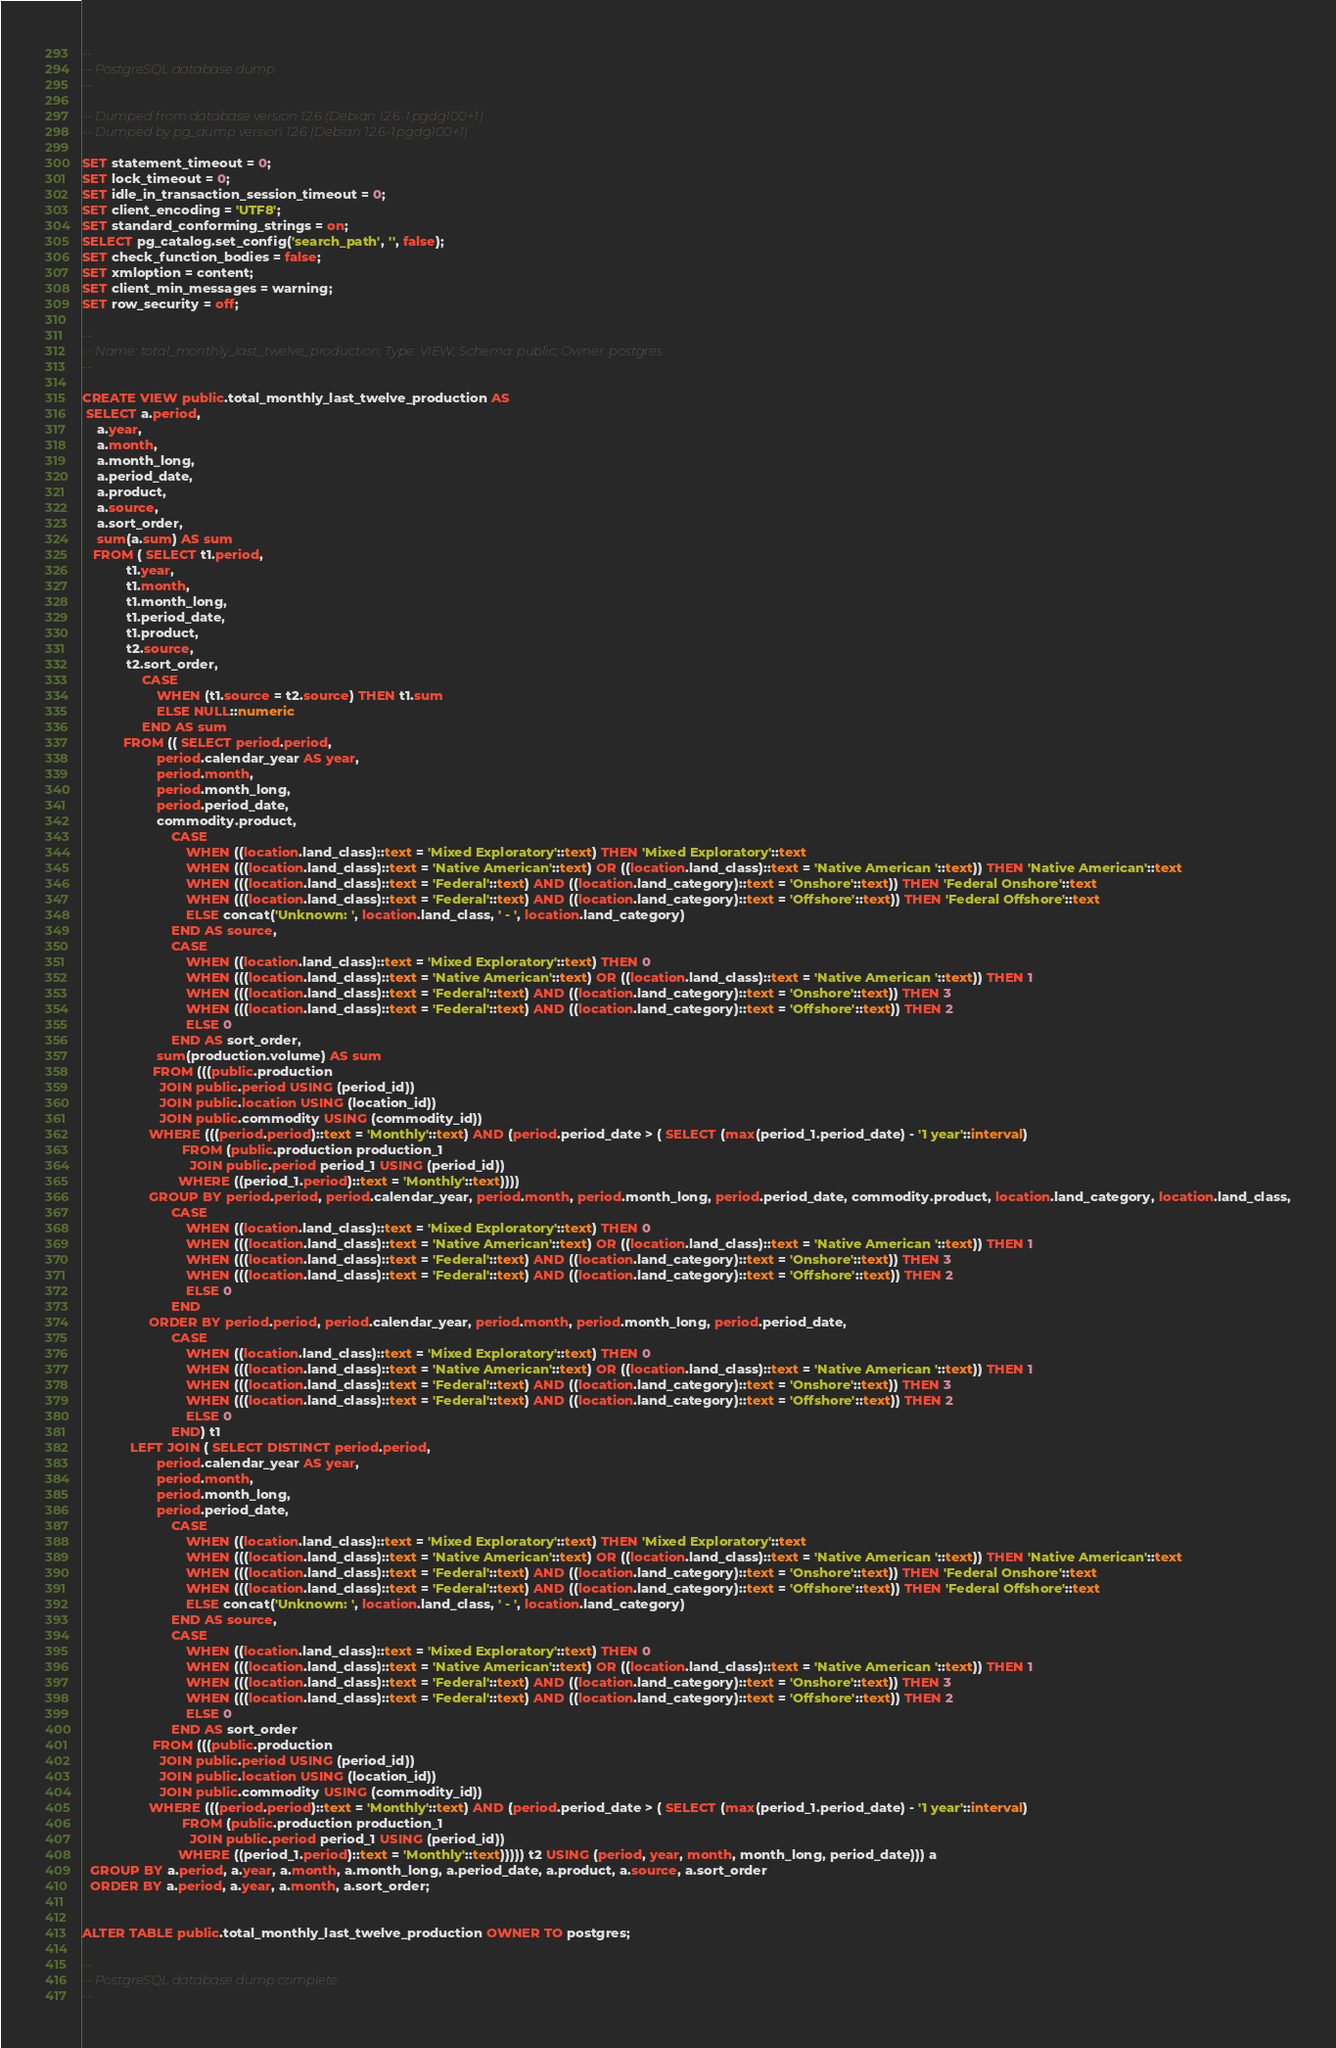<code> <loc_0><loc_0><loc_500><loc_500><_SQL_>--
-- PostgreSQL database dump
--

-- Dumped from database version 12.6 (Debian 12.6-1.pgdg100+1)
-- Dumped by pg_dump version 12.6 (Debian 12.6-1.pgdg100+1)

SET statement_timeout = 0;
SET lock_timeout = 0;
SET idle_in_transaction_session_timeout = 0;
SET client_encoding = 'UTF8';
SET standard_conforming_strings = on;
SELECT pg_catalog.set_config('search_path', '', false);
SET check_function_bodies = false;
SET xmloption = content;
SET client_min_messages = warning;
SET row_security = off;

--
-- Name: total_monthly_last_twelve_production; Type: VIEW; Schema: public; Owner: postgres
--

CREATE VIEW public.total_monthly_last_twelve_production AS
 SELECT a.period,
    a.year,
    a.month,
    a.month_long,
    a.period_date,
    a.product,
    a.source,
    a.sort_order,
    sum(a.sum) AS sum
   FROM ( SELECT t1.period,
            t1.year,
            t1.month,
            t1.month_long,
            t1.period_date,
            t1.product,
            t2.source,
            t2.sort_order,
                CASE
                    WHEN (t1.source = t2.source) THEN t1.sum
                    ELSE NULL::numeric
                END AS sum
           FROM (( SELECT period.period,
                    period.calendar_year AS year,
                    period.month,
                    period.month_long,
                    period.period_date,
                    commodity.product,
                        CASE
                            WHEN ((location.land_class)::text = 'Mixed Exploratory'::text) THEN 'Mixed Exploratory'::text
                            WHEN (((location.land_class)::text = 'Native American'::text) OR ((location.land_class)::text = 'Native American '::text)) THEN 'Native American'::text
                            WHEN (((location.land_class)::text = 'Federal'::text) AND ((location.land_category)::text = 'Onshore'::text)) THEN 'Federal Onshore'::text
                            WHEN (((location.land_class)::text = 'Federal'::text) AND ((location.land_category)::text = 'Offshore'::text)) THEN 'Federal Offshore'::text
                            ELSE concat('Unknown: ', location.land_class, ' - ', location.land_category)
                        END AS source,
                        CASE
                            WHEN ((location.land_class)::text = 'Mixed Exploratory'::text) THEN 0
                            WHEN (((location.land_class)::text = 'Native American'::text) OR ((location.land_class)::text = 'Native American '::text)) THEN 1
                            WHEN (((location.land_class)::text = 'Federal'::text) AND ((location.land_category)::text = 'Onshore'::text)) THEN 3
                            WHEN (((location.land_class)::text = 'Federal'::text) AND ((location.land_category)::text = 'Offshore'::text)) THEN 2
                            ELSE 0
                        END AS sort_order,
                    sum(production.volume) AS sum
                   FROM (((public.production
                     JOIN public.period USING (period_id))
                     JOIN public.location USING (location_id))
                     JOIN public.commodity USING (commodity_id))
                  WHERE (((period.period)::text = 'Monthly'::text) AND (period.period_date > ( SELECT (max(period_1.period_date) - '1 year'::interval)
                           FROM (public.production production_1
                             JOIN public.period period_1 USING (period_id))
                          WHERE ((period_1.period)::text = 'Monthly'::text))))
                  GROUP BY period.period, period.calendar_year, period.month, period.month_long, period.period_date, commodity.product, location.land_category, location.land_class,
                        CASE
                            WHEN ((location.land_class)::text = 'Mixed Exploratory'::text) THEN 0
                            WHEN (((location.land_class)::text = 'Native American'::text) OR ((location.land_class)::text = 'Native American '::text)) THEN 1
                            WHEN (((location.land_class)::text = 'Federal'::text) AND ((location.land_category)::text = 'Onshore'::text)) THEN 3
                            WHEN (((location.land_class)::text = 'Federal'::text) AND ((location.land_category)::text = 'Offshore'::text)) THEN 2
                            ELSE 0
                        END
                  ORDER BY period.period, period.calendar_year, period.month, period.month_long, period.period_date,
                        CASE
                            WHEN ((location.land_class)::text = 'Mixed Exploratory'::text) THEN 0
                            WHEN (((location.land_class)::text = 'Native American'::text) OR ((location.land_class)::text = 'Native American '::text)) THEN 1
                            WHEN (((location.land_class)::text = 'Federal'::text) AND ((location.land_category)::text = 'Onshore'::text)) THEN 3
                            WHEN (((location.land_class)::text = 'Federal'::text) AND ((location.land_category)::text = 'Offshore'::text)) THEN 2
                            ELSE 0
                        END) t1
             LEFT JOIN ( SELECT DISTINCT period.period,
                    period.calendar_year AS year,
                    period.month,
                    period.month_long,
                    period.period_date,
                        CASE
                            WHEN ((location.land_class)::text = 'Mixed Exploratory'::text) THEN 'Mixed Exploratory'::text
                            WHEN (((location.land_class)::text = 'Native American'::text) OR ((location.land_class)::text = 'Native American '::text)) THEN 'Native American'::text
                            WHEN (((location.land_class)::text = 'Federal'::text) AND ((location.land_category)::text = 'Onshore'::text)) THEN 'Federal Onshore'::text
                            WHEN (((location.land_class)::text = 'Federal'::text) AND ((location.land_category)::text = 'Offshore'::text)) THEN 'Federal Offshore'::text
                            ELSE concat('Unknown: ', location.land_class, ' - ', location.land_category)
                        END AS source,
                        CASE
                            WHEN ((location.land_class)::text = 'Mixed Exploratory'::text) THEN 0
                            WHEN (((location.land_class)::text = 'Native American'::text) OR ((location.land_class)::text = 'Native American '::text)) THEN 1
                            WHEN (((location.land_class)::text = 'Federal'::text) AND ((location.land_category)::text = 'Onshore'::text)) THEN 3
                            WHEN (((location.land_class)::text = 'Federal'::text) AND ((location.land_category)::text = 'Offshore'::text)) THEN 2
                            ELSE 0
                        END AS sort_order
                   FROM (((public.production
                     JOIN public.period USING (period_id))
                     JOIN public.location USING (location_id))
                     JOIN public.commodity USING (commodity_id))
                  WHERE (((period.period)::text = 'Monthly'::text) AND (period.period_date > ( SELECT (max(period_1.period_date) - '1 year'::interval)
                           FROM (public.production production_1
                             JOIN public.period period_1 USING (period_id))
                          WHERE ((period_1.period)::text = 'Monthly'::text))))) t2 USING (period, year, month, month_long, period_date))) a
  GROUP BY a.period, a.year, a.month, a.month_long, a.period_date, a.product, a.source, a.sort_order
  ORDER BY a.period, a.year, a.month, a.sort_order;


ALTER TABLE public.total_monthly_last_twelve_production OWNER TO postgres;

--
-- PostgreSQL database dump complete
--

</code> 